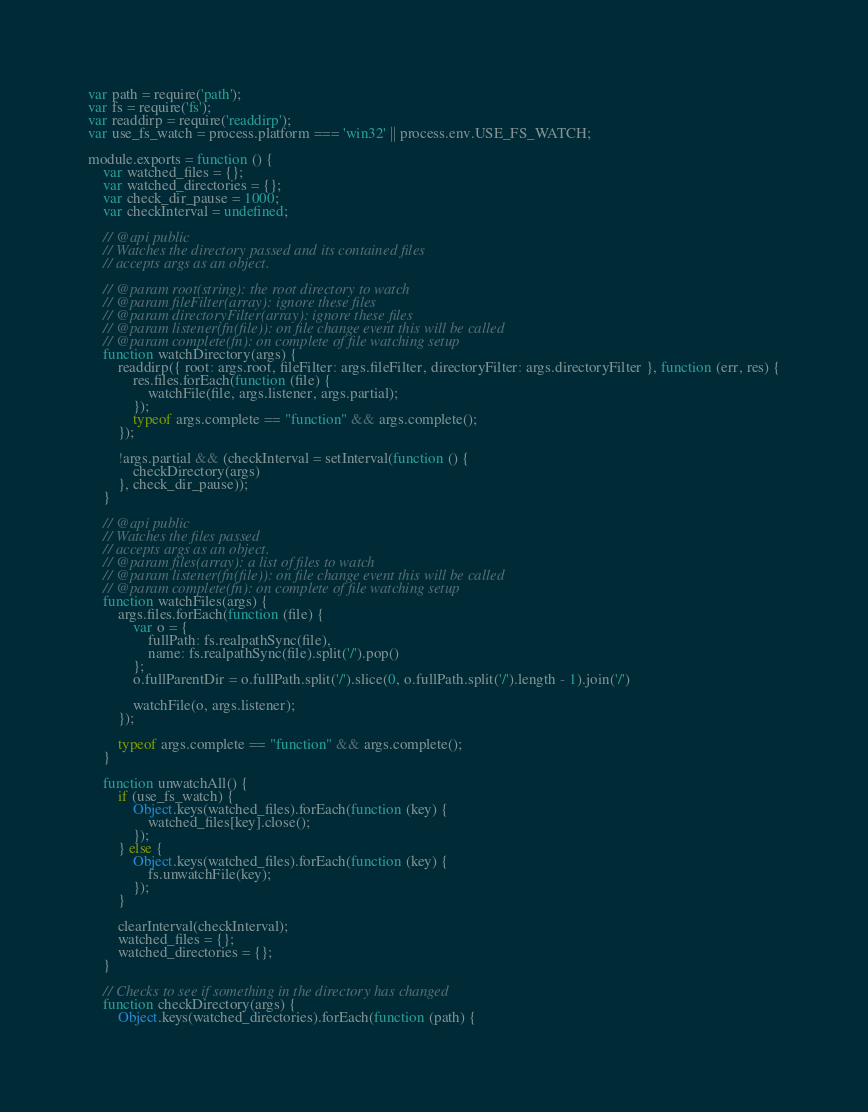Convert code to text. <code><loc_0><loc_0><loc_500><loc_500><_JavaScript_>var path = require('path');
var fs = require('fs');
var readdirp = require('readdirp');
var use_fs_watch = process.platform === 'win32' || process.env.USE_FS_WATCH;

module.exports = function () {
    var watched_files = {};
    var watched_directories = {};
    var check_dir_pause = 1000;
    var checkInterval = undefined;

    // @api public
    // Watches the directory passed and its contained files
    // accepts args as an object.

    // @param root(string): the root directory to watch
    // @param fileFilter(array): ignore these files
    // @param directoryFilter(array): ignore these files
    // @param listener(fn(file)): on file change event this will be called
    // @param complete(fn): on complete of file watching setup
    function watchDirectory(args) {
        readdirp({ root: args.root, fileFilter: args.fileFilter, directoryFilter: args.directoryFilter }, function (err, res) {
            res.files.forEach(function (file) {
                watchFile(file, args.listener, args.partial);
            });
            typeof args.complete == "function" && args.complete();
        });

        !args.partial && (checkInterval = setInterval(function () {
            checkDirectory(args)
        }, check_dir_pause));
    }

    // @api public
    // Watches the files passed
    // accepts args as an object.
    // @param files(array): a list of files to watch
    // @param listener(fn(file)): on file change event this will be called
    // @param complete(fn): on complete of file watching setup
    function watchFiles(args) {
        args.files.forEach(function (file) {
            var o = {
                fullPath: fs.realpathSync(file),
                name: fs.realpathSync(file).split('/').pop()
            };
            o.fullParentDir = o.fullPath.split('/').slice(0, o.fullPath.split('/').length - 1).join('/')

            watchFile(o, args.listener);
        });

        typeof args.complete == "function" && args.complete();
    }

    function unwatchAll() {
        if (use_fs_watch) {
            Object.keys(watched_files).forEach(function (key) {
                watched_files[key].close();
            });
        } else {
            Object.keys(watched_files).forEach(function (key) {
                fs.unwatchFile(key);
            });
        }

        clearInterval(checkInterval);
        watched_files = {};
        watched_directories = {};
    }

    // Checks to see if something in the directory has changed
    function checkDirectory(args) {
        Object.keys(watched_directories).forEach(function (path) {</code> 